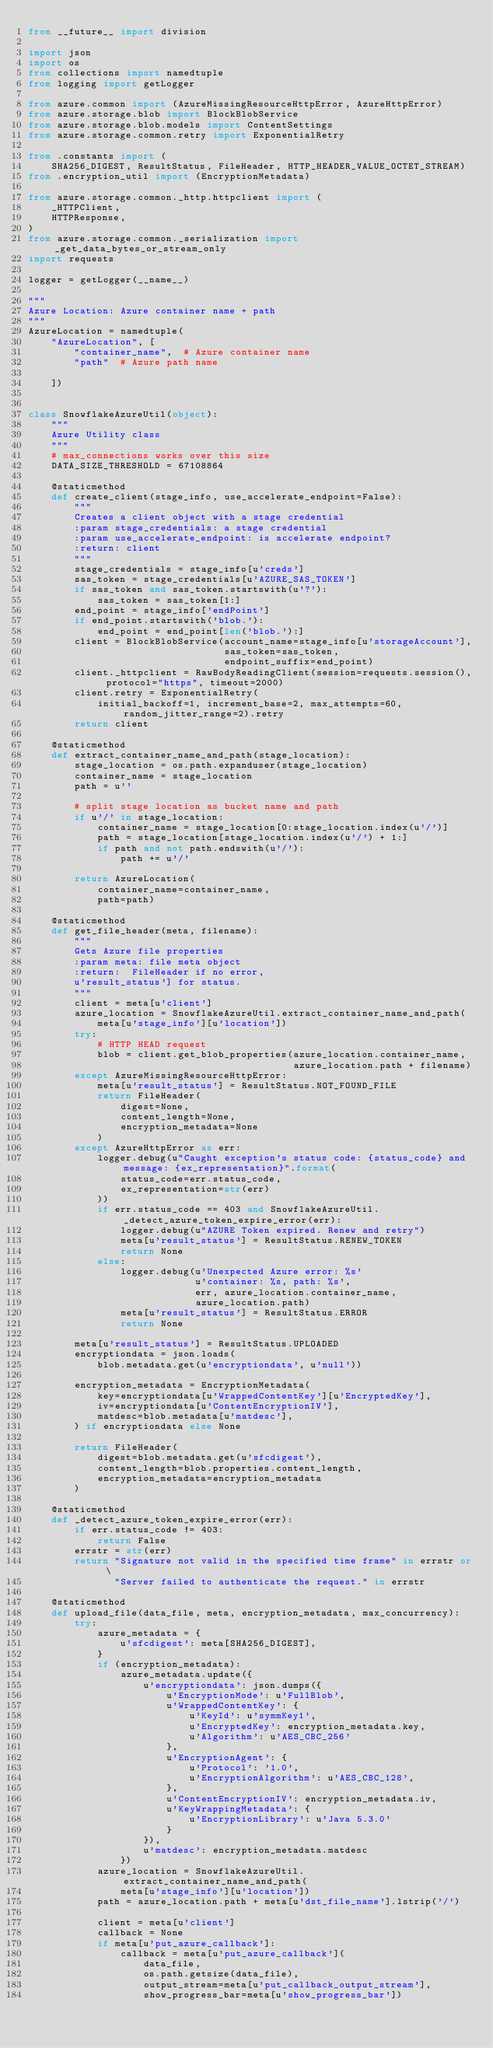<code> <loc_0><loc_0><loc_500><loc_500><_Python_>from __future__ import division

import json
import os
from collections import namedtuple
from logging import getLogger

from azure.common import (AzureMissingResourceHttpError, AzureHttpError)
from azure.storage.blob import BlockBlobService
from azure.storage.blob.models import ContentSettings
from azure.storage.common.retry import ExponentialRetry

from .constants import (
    SHA256_DIGEST, ResultStatus, FileHeader, HTTP_HEADER_VALUE_OCTET_STREAM)
from .encryption_util import (EncryptionMetadata)

from azure.storage.common._http.httpclient import (
    _HTTPClient,
    HTTPResponse,
)
from azure.storage.common._serialization import _get_data_bytes_or_stream_only
import requests

logger = getLogger(__name__)

"""
Azure Location: Azure container name + path
"""
AzureLocation = namedtuple(
    "AzureLocation", [
        "container_name",  # Azure container name
        "path"  # Azure path name

    ])


class SnowflakeAzureUtil(object):
    """
    Azure Utility class
    """
    # max_connections works over this size
    DATA_SIZE_THRESHOLD = 67108864

    @staticmethod
    def create_client(stage_info, use_accelerate_endpoint=False):
        """
        Creates a client object with a stage credential
        :param stage_credentials: a stage credential
        :param use_accelerate_endpoint: is accelerate endpoint?
        :return: client
        """
        stage_credentials = stage_info[u'creds']
        sas_token = stage_credentials[u'AZURE_SAS_TOKEN']
        if sas_token and sas_token.startswith(u'?'):
            sas_token = sas_token[1:]
        end_point = stage_info['endPoint']
        if end_point.startswith('blob.'):
            end_point = end_point[len('blob.'):]
        client = BlockBlobService(account_name=stage_info[u'storageAccount'],
                                  sas_token=sas_token,
                                  endpoint_suffix=end_point)
        client._httpclient = RawBodyReadingClient(session=requests.session(), protocol="https", timeout=2000)
        client.retry = ExponentialRetry(
            initial_backoff=1, increment_base=2, max_attempts=60, random_jitter_range=2).retry
        return client

    @staticmethod
    def extract_container_name_and_path(stage_location):
        stage_location = os.path.expanduser(stage_location)
        container_name = stage_location
        path = u''

        # split stage location as bucket name and path
        if u'/' in stage_location:
            container_name = stage_location[0:stage_location.index(u'/')]
            path = stage_location[stage_location.index(u'/') + 1:]
            if path and not path.endswith(u'/'):
                path += u'/'

        return AzureLocation(
            container_name=container_name,
            path=path)

    @staticmethod
    def get_file_header(meta, filename):
        """
        Gets Azure file properties
        :param meta: file meta object
        :return:  FileHeader if no error,
        u'result_status'] for status.
        """
        client = meta[u'client']
        azure_location = SnowflakeAzureUtil.extract_container_name_and_path(
            meta[u'stage_info'][u'location'])
        try:
            # HTTP HEAD request
            blob = client.get_blob_properties(azure_location.container_name,
                                              azure_location.path + filename)
        except AzureMissingResourceHttpError:
            meta[u'result_status'] = ResultStatus.NOT_FOUND_FILE
            return FileHeader(
                digest=None,
                content_length=None,
                encryption_metadata=None
            )
        except AzureHttpError as err:
            logger.debug(u"Caught exception's status code: {status_code} and message: {ex_representation}".format(
                status_code=err.status_code,
                ex_representation=str(err)
            ))
            if err.status_code == 403 and SnowflakeAzureUtil._detect_azure_token_expire_error(err):
                logger.debug(u"AZURE Token expired. Renew and retry")
                meta[u'result_status'] = ResultStatus.RENEW_TOKEN
                return None
            else:
                logger.debug(u'Unexpected Azure error: %s'
                             u'container: %s, path: %s',
                             err, azure_location.container_name,
                             azure_location.path)
                meta[u'result_status'] = ResultStatus.ERROR
                return None

        meta[u'result_status'] = ResultStatus.UPLOADED
        encryptiondata = json.loads(
            blob.metadata.get(u'encryptiondata', u'null'))

        encryption_metadata = EncryptionMetadata(
            key=encryptiondata[u'WrappedContentKey'][u'EncryptedKey'],
            iv=encryptiondata[u'ContentEncryptionIV'],
            matdesc=blob.metadata[u'matdesc'],
        ) if encryptiondata else None

        return FileHeader(
            digest=blob.metadata.get(u'sfcdigest'),
            content_length=blob.properties.content_length,
            encryption_metadata=encryption_metadata
        )

    @staticmethod
    def _detect_azure_token_expire_error(err):
        if err.status_code != 403:
            return False
        errstr = str(err)
        return "Signature not valid in the specified time frame" in errstr or \
               "Server failed to authenticate the request." in errstr

    @staticmethod
    def upload_file(data_file, meta, encryption_metadata, max_concurrency):
        try:
            azure_metadata = {
                u'sfcdigest': meta[SHA256_DIGEST],
            }
            if (encryption_metadata):
                azure_metadata.update({
                    u'encryptiondata': json.dumps({
                        u'EncryptionMode': u'FullBlob',
                        u'WrappedContentKey': {
                            u'KeyId': u'symmKey1',
                            u'EncryptedKey': encryption_metadata.key,
                            u'Algorithm': u'AES_CBC_256'
                        },
                        u'EncryptionAgent': {
                            u'Protocol': '1.0',
                            u'EncryptionAlgorithm': u'AES_CBC_128',
                        },
                        u'ContentEncryptionIV': encryption_metadata.iv,
                        u'KeyWrappingMetadata': {
                            u'EncryptionLibrary': u'Java 5.3.0'
                        }
                    }),
                    u'matdesc': encryption_metadata.matdesc
                })
            azure_location = SnowflakeAzureUtil.extract_container_name_and_path(
                meta[u'stage_info'][u'location'])
            path = azure_location.path + meta[u'dst_file_name'].lstrip('/')

            client = meta[u'client']
            callback = None
            if meta[u'put_azure_callback']:
                callback = meta[u'put_azure_callback'](
                    data_file,
                    os.path.getsize(data_file),
                    output_stream=meta[u'put_callback_output_stream'],
                    show_progress_bar=meta[u'show_progress_bar'])
</code> 